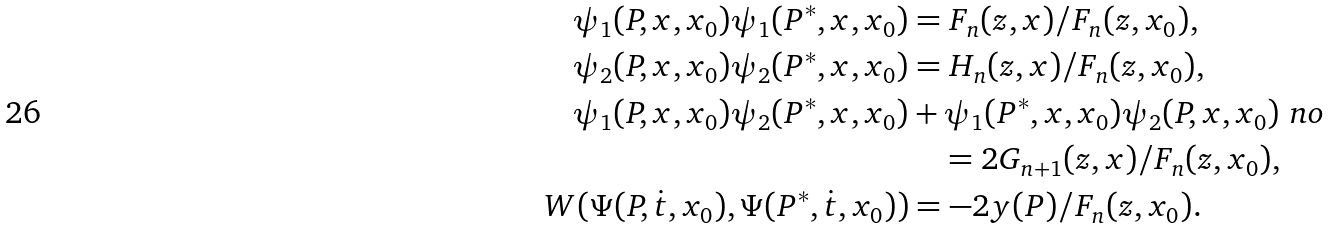Convert formula to latex. <formula><loc_0><loc_0><loc_500><loc_500>\psi _ { 1 } ( P , x , x _ { 0 } ) \psi _ { 1 } ( P ^ { * } , x , x _ { 0 } ) & = F _ { n } ( z , x ) / F _ { n } ( z , x _ { 0 } ) , \\ \psi _ { 2 } ( P , x , x _ { 0 } ) \psi _ { 2 } ( P ^ { * } , x , x _ { 0 } ) & = H _ { n } ( z , x ) / F _ { n } ( z , x _ { 0 } ) , \\ \psi _ { 1 } ( P , x , x _ { 0 } ) \psi _ { 2 } ( P ^ { * } , x , x _ { 0 } ) & + \psi _ { 1 } ( P ^ { * } , x , x _ { 0 } ) \psi _ { 2 } ( P , x , x _ { 0 } ) \ n o \\ & \quad = 2 G _ { n + 1 } ( z , x ) / F _ { n } ( z , x _ { 0 } ) , \\ W ( \Psi ( P , \dot { t } , x _ { 0 } ) , \Psi ( P ^ { * } , \dot { t } , x _ { 0 } ) ) & = - 2 y ( P ) / F _ { n } ( z , x _ { 0 } ) .</formula> 